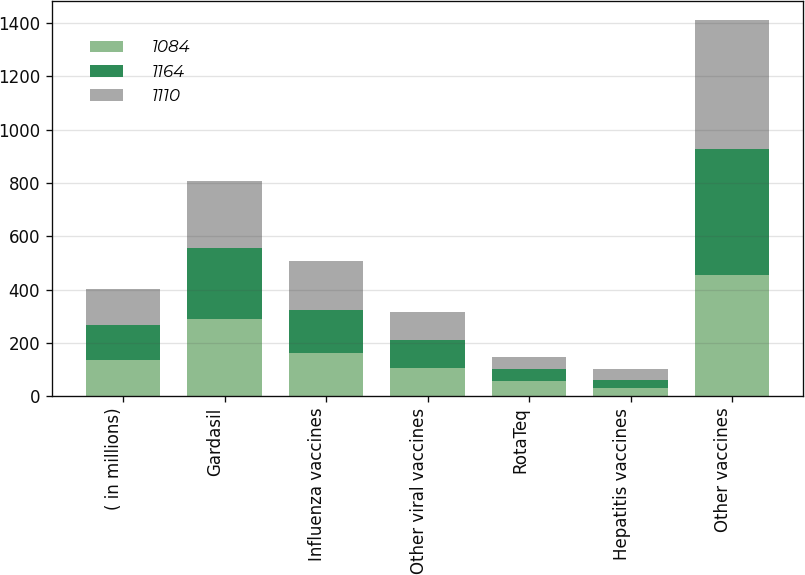Convert chart. <chart><loc_0><loc_0><loc_500><loc_500><stacked_bar_chart><ecel><fcel>( in millions)<fcel>Gardasil<fcel>Influenza vaccines<fcel>Other viral vaccines<fcel>RotaTeq<fcel>Hepatitis vaccines<fcel>Other vaccines<nl><fcel>1084<fcel>134<fcel>291<fcel>162<fcel>104<fcel>55<fcel>31<fcel>453<nl><fcel>1164<fcel>134<fcel>264<fcel>161<fcel>107<fcel>47<fcel>31<fcel>474<nl><fcel>1110<fcel>134<fcel>253<fcel>183<fcel>105<fcel>44<fcel>39<fcel>486<nl></chart> 